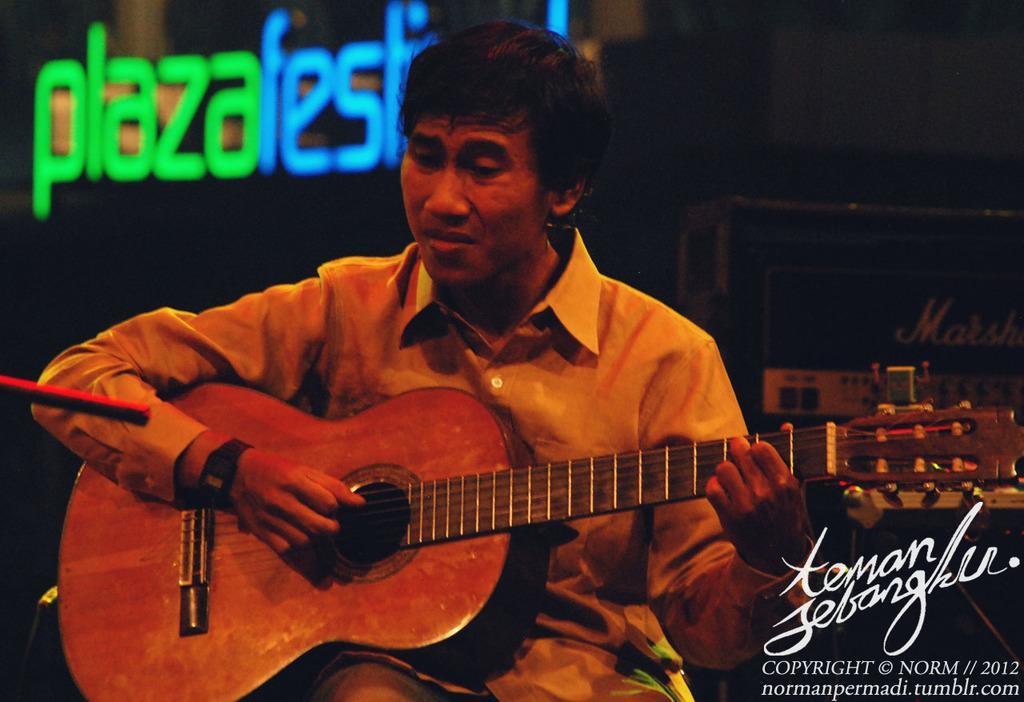Can you describe this image briefly? In this image, there is a person sitting and playing a guitar. This person wearing clothes and watch. 